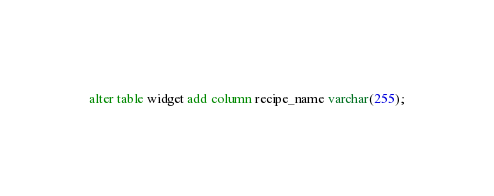Convert code to text. <code><loc_0><loc_0><loc_500><loc_500><_SQL_>alter table widget add column recipe_name varchar(255);</code> 